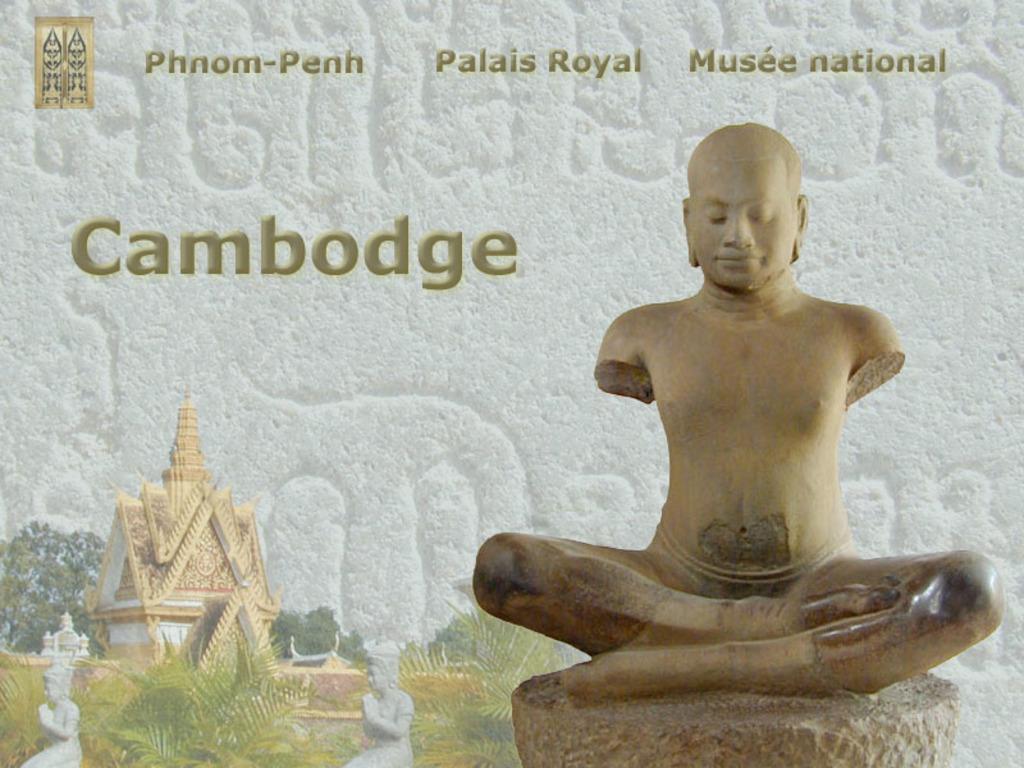Describe this image in one or two sentences. In this image I can see the statue which is in brown color. To the side there are few more statues and the plants. I can also see the building and trees in the back. And there is a name cambodge is written on the wall. 